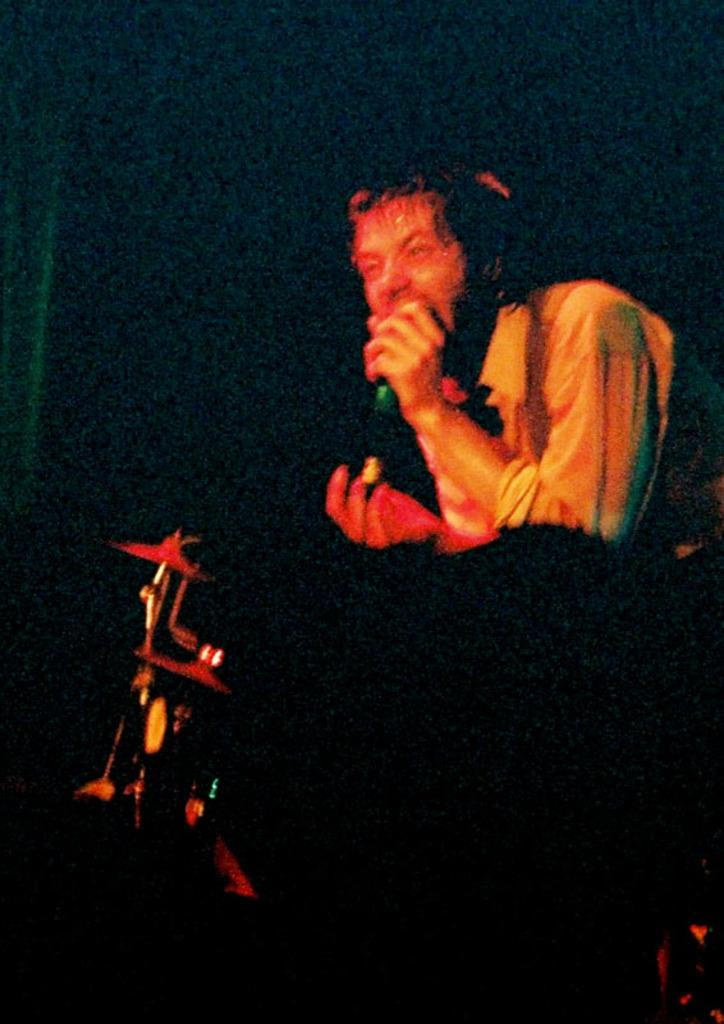Who is the main subject in the image? There is a man in the center of the image. What is the man holding in his hand? The man is holding a mic in his hand. What is the man's relationship to the other people in the image? The man is in front of a band, which suggests he might be a singer or performer. How many boats are visible in the image? There are no boats present in the image. Is there a crown visible on the man's head in the image? There is no crown visible on the man's head in the image. 